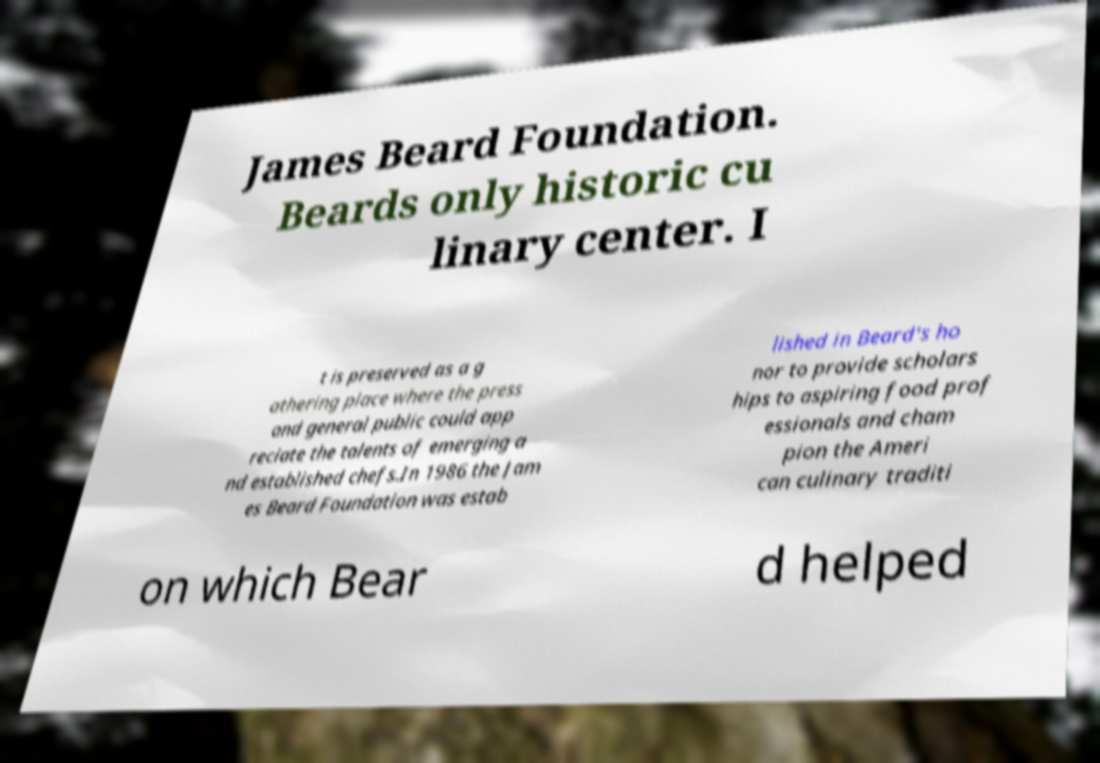Please read and relay the text visible in this image. What does it say? James Beard Foundation. Beards only historic cu linary center. I t is preserved as a g athering place where the press and general public could app reciate the talents of emerging a nd established chefs.In 1986 the Jam es Beard Foundation was estab lished in Beard's ho nor to provide scholars hips to aspiring food prof essionals and cham pion the Ameri can culinary traditi on which Bear d helped 